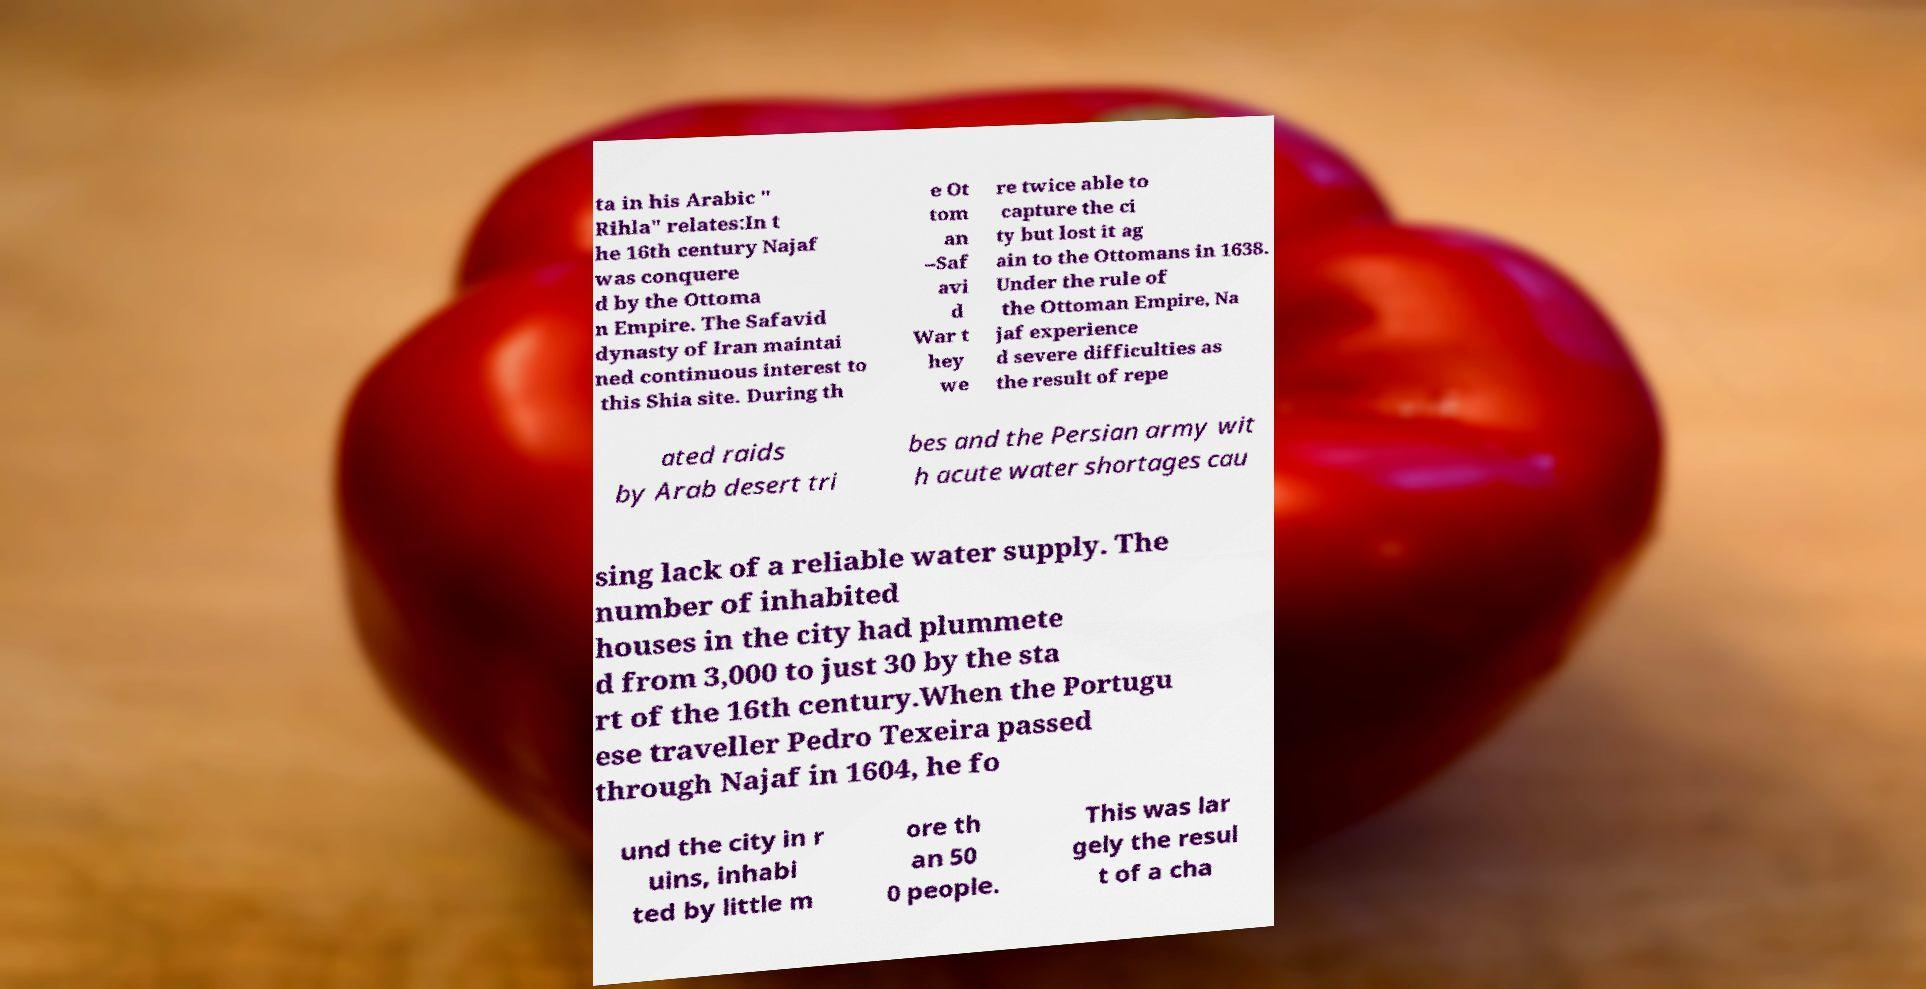I need the written content from this picture converted into text. Can you do that? ta in his Arabic " Rihla" relates:In t he 16th century Najaf was conquere d by the Ottoma n Empire. The Safavid dynasty of Iran maintai ned continuous interest to this Shia site. During th e Ot tom an –Saf avi d War t hey we re twice able to capture the ci ty but lost it ag ain to the Ottomans in 1638. Under the rule of the Ottoman Empire, Na jaf experience d severe difficulties as the result of repe ated raids by Arab desert tri bes and the Persian army wit h acute water shortages cau sing lack of a reliable water supply. The number of inhabited houses in the city had plummete d from 3,000 to just 30 by the sta rt of the 16th century.When the Portugu ese traveller Pedro Texeira passed through Najaf in 1604, he fo und the city in r uins, inhabi ted by little m ore th an 50 0 people. This was lar gely the resul t of a cha 